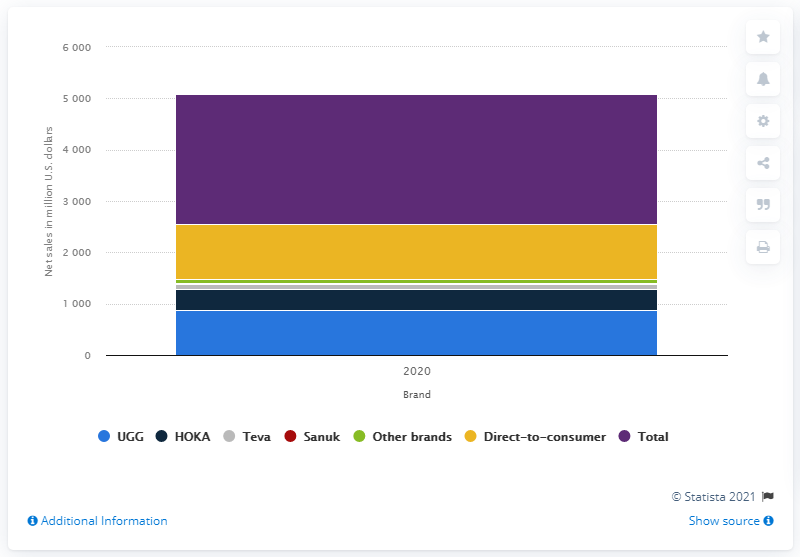Indicate a few pertinent items in this graphic. In the year 2020, the UGG brand generated net sales of approximately 871.8 million U.S. dollars. In 2020, the net sales of the UGG brand in the United States were 871.8 million dollars. 